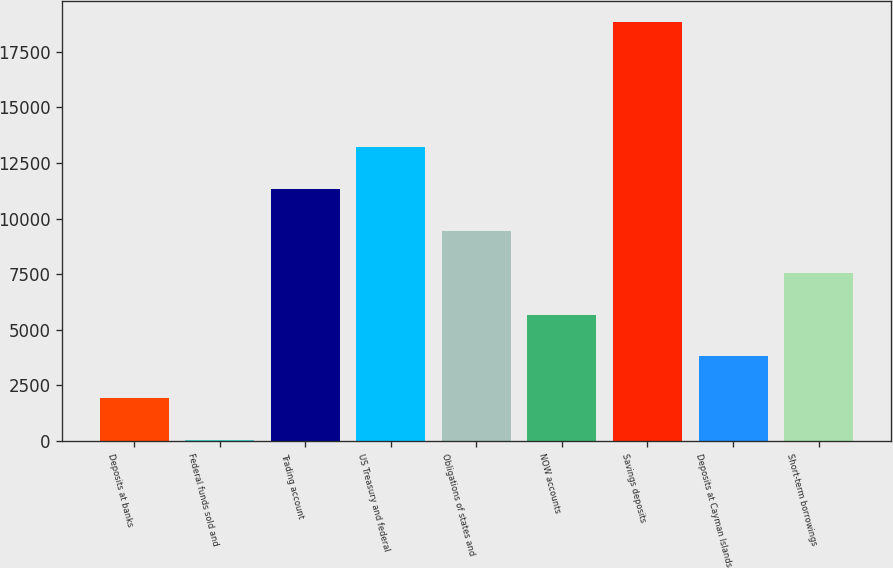Convert chart. <chart><loc_0><loc_0><loc_500><loc_500><bar_chart><fcel>Deposits at banks<fcel>Federal funds sold and<fcel>Trading account<fcel>US Treasury and federal<fcel>Obligations of states and<fcel>NOW accounts<fcel>Savings deposits<fcel>Deposits at Cayman Islands<fcel>Short-term borrowings<nl><fcel>1917.6<fcel>35<fcel>11330.6<fcel>13213.2<fcel>9448<fcel>5682.8<fcel>18861<fcel>3800.2<fcel>7565.4<nl></chart> 